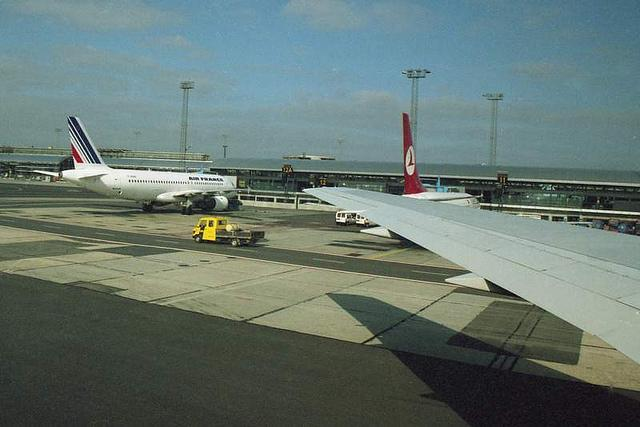What fuel does the plane require? Please explain your reasoning. jetfuel. These are airplanes 